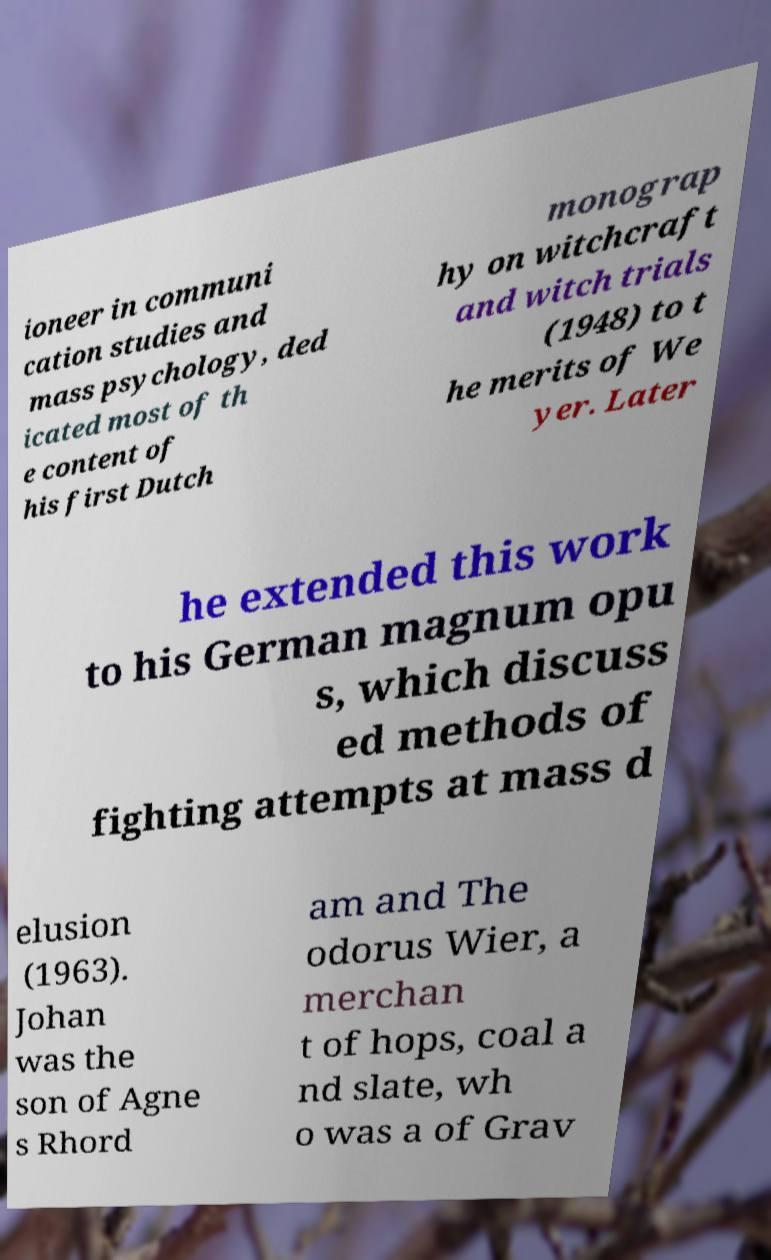What messages or text are displayed in this image? I need them in a readable, typed format. ioneer in communi cation studies and mass psychology, ded icated most of th e content of his first Dutch monograp hy on witchcraft and witch trials (1948) to t he merits of We yer. Later he extended this work to his German magnum opu s, which discuss ed methods of fighting attempts at mass d elusion (1963). Johan was the son of Agne s Rhord am and The odorus Wier, a merchan t of hops, coal a nd slate, wh o was a of Grav 